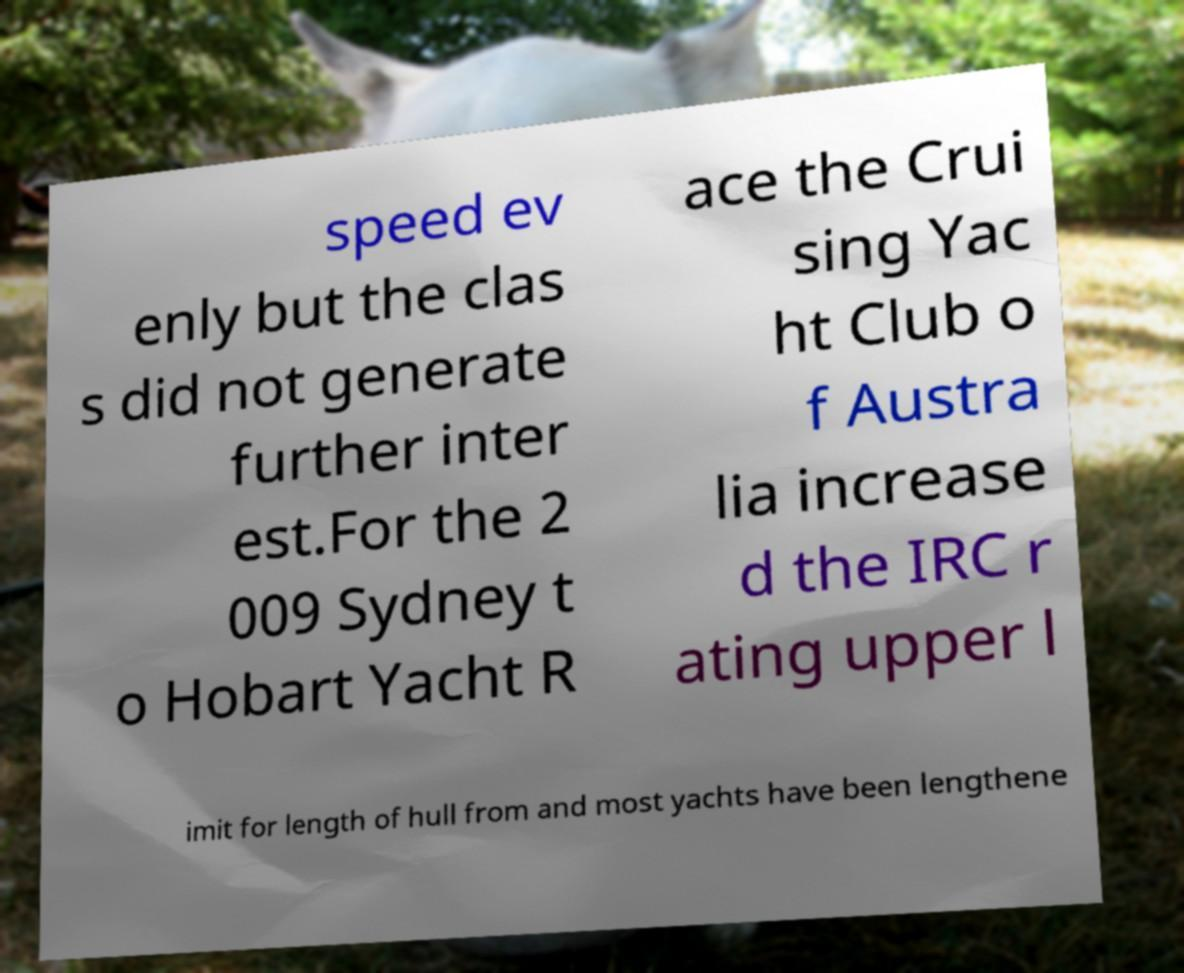Can you read and provide the text displayed in the image?This photo seems to have some interesting text. Can you extract and type it out for me? speed ev enly but the clas s did not generate further inter est.For the 2 009 Sydney t o Hobart Yacht R ace the Crui sing Yac ht Club o f Austra lia increase d the IRC r ating upper l imit for length of hull from and most yachts have been lengthene 